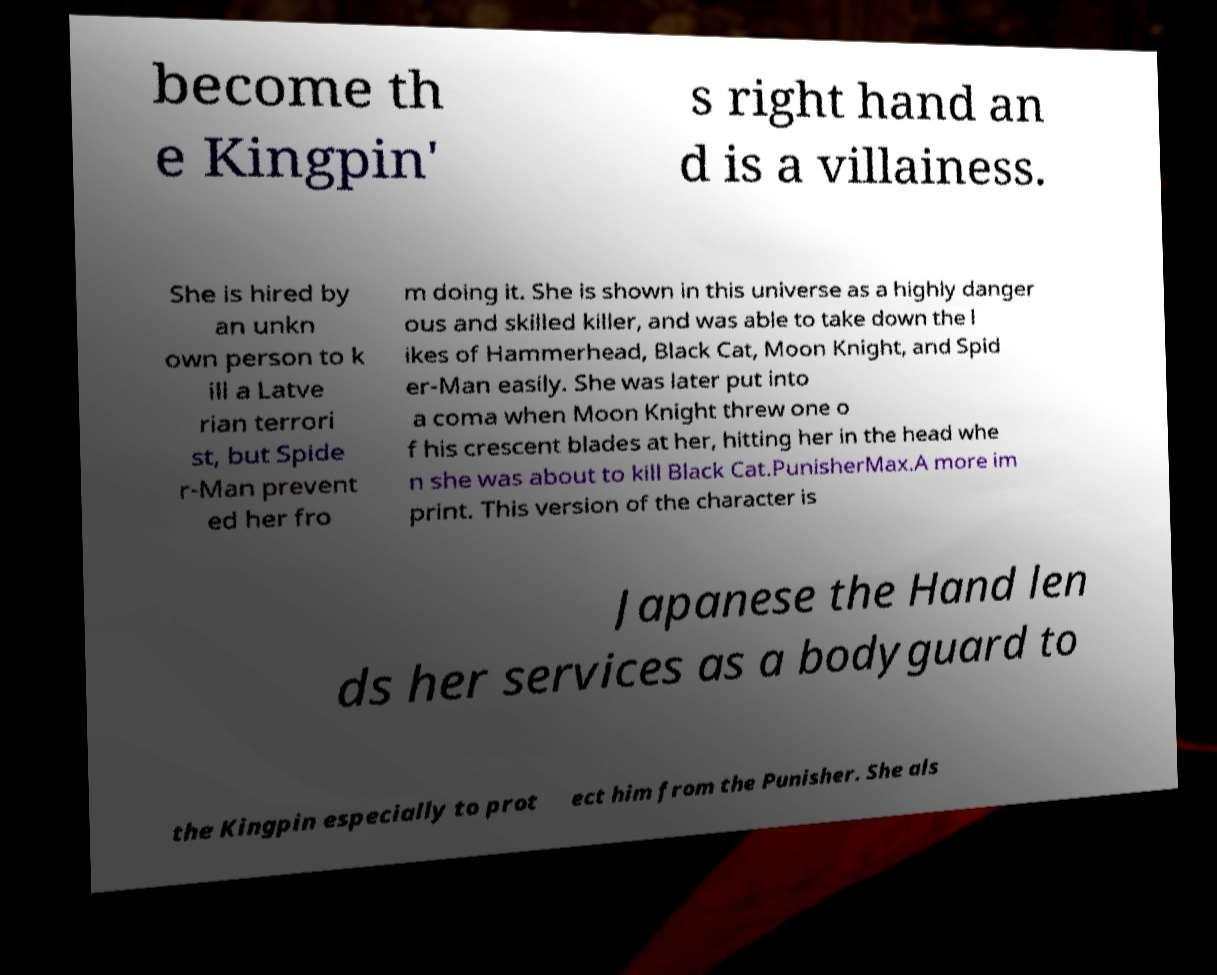Could you extract and type out the text from this image? become th e Kingpin' s right hand an d is a villainess. She is hired by an unkn own person to k ill a Latve rian terrori st, but Spide r-Man prevent ed her fro m doing it. She is shown in this universe as a highly danger ous and skilled killer, and was able to take down the l ikes of Hammerhead, Black Cat, Moon Knight, and Spid er-Man easily. She was later put into a coma when Moon Knight threw one o f his crescent blades at her, hitting her in the head whe n she was about to kill Black Cat.PunisherMax.A more im print. This version of the character is Japanese the Hand len ds her services as a bodyguard to the Kingpin especially to prot ect him from the Punisher. She als 